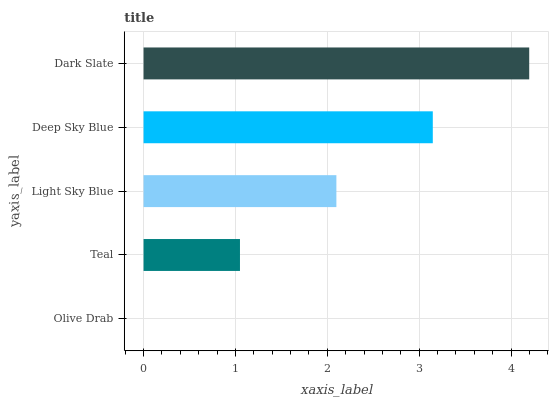Is Olive Drab the minimum?
Answer yes or no. Yes. Is Dark Slate the maximum?
Answer yes or no. Yes. Is Teal the minimum?
Answer yes or no. No. Is Teal the maximum?
Answer yes or no. No. Is Teal greater than Olive Drab?
Answer yes or no. Yes. Is Olive Drab less than Teal?
Answer yes or no. Yes. Is Olive Drab greater than Teal?
Answer yes or no. No. Is Teal less than Olive Drab?
Answer yes or no. No. Is Light Sky Blue the high median?
Answer yes or no. Yes. Is Light Sky Blue the low median?
Answer yes or no. Yes. Is Dark Slate the high median?
Answer yes or no. No. Is Dark Slate the low median?
Answer yes or no. No. 